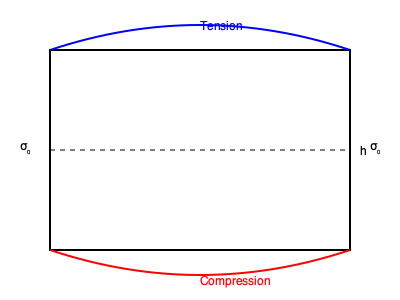Analyze the stress distribution on the walls of an underground parking structure as shown in the diagram. If the height of the wall is $h$ and the lateral earth pressure at rest is $\sigma_0$, determine the maximum bending moment $M_{max}$ in the wall. Express your answer in terms of $\sigma_0$ and $h$. To solve this problem, we'll follow these steps:

1) The diagram shows a typical stress distribution on an underground parking structure wall. The top of the wall experiences tension, while the bottom experiences compression.

2) The lateral earth pressure at rest ($\sigma_0$) is constant along the height of the wall. This creates a uniform load distribution.

3) For a uniformly distributed load on a fixed-end beam (which is how we can model this wall), the maximum bending moment occurs at the fixed ends.

4) The formula for maximum bending moment in a fixed-end beam with uniform load is:

   $$M_{max} = \frac{wL^2}{12}$$

   Where $w$ is the uniform load per unit length, and $L$ is the length of the beam.

5) In our case, $w = \sigma_0$ (the uniform lateral earth pressure), and $L = h$ (the height of the wall).

6) Substituting these into the formula:

   $$M_{max} = \frac{\sigma_0 h^2}{12}$$

7) This gives us the maximum bending moment in terms of $\sigma_0$ and $h$, as required.
Answer: $M_{max} = \frac{\sigma_0 h^2}{12}$ 